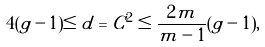Convert formula to latex. <formula><loc_0><loc_0><loc_500><loc_500>4 ( g - 1 ) \leq d = C ^ { 2 } \leq \frac { 2 m } { m - 1 } ( g - 1 ) ,</formula> 